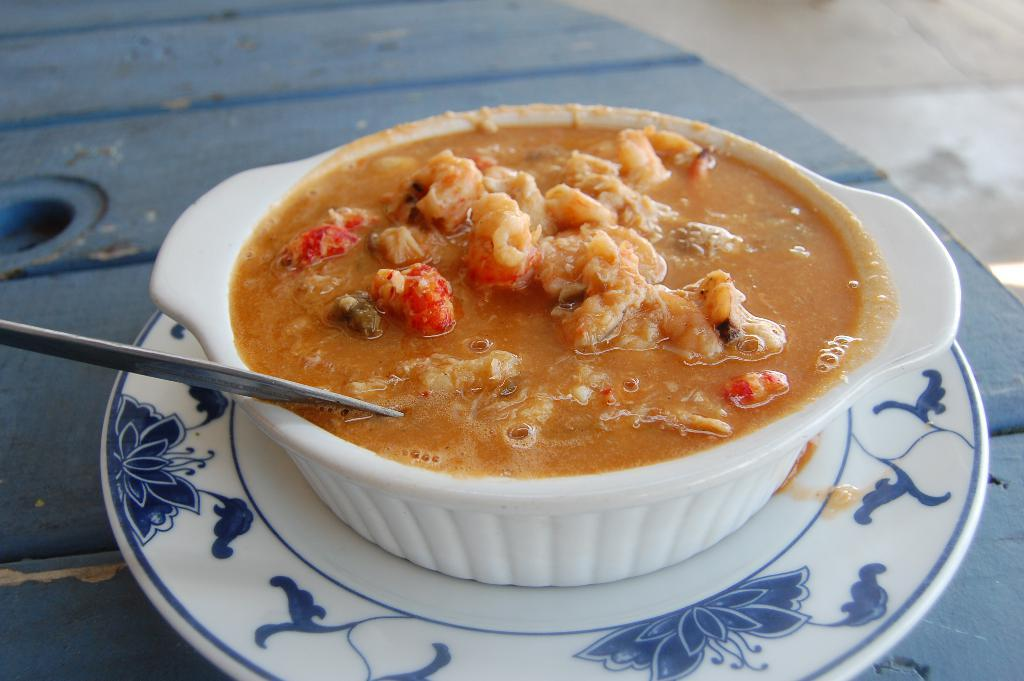What is on the table in the image? There is a plate on a table in the image. What is on the plate? The plate contains a bowl with food. What utensil is in the bowl? There is a spoon in the bowl. What can be seen below the table in the image? There is a floor visible in the image. What type of insurance is being discussed in the image? There is no discussion of insurance in the image; it features a plate with a bowl of food and a spoon on a table. 